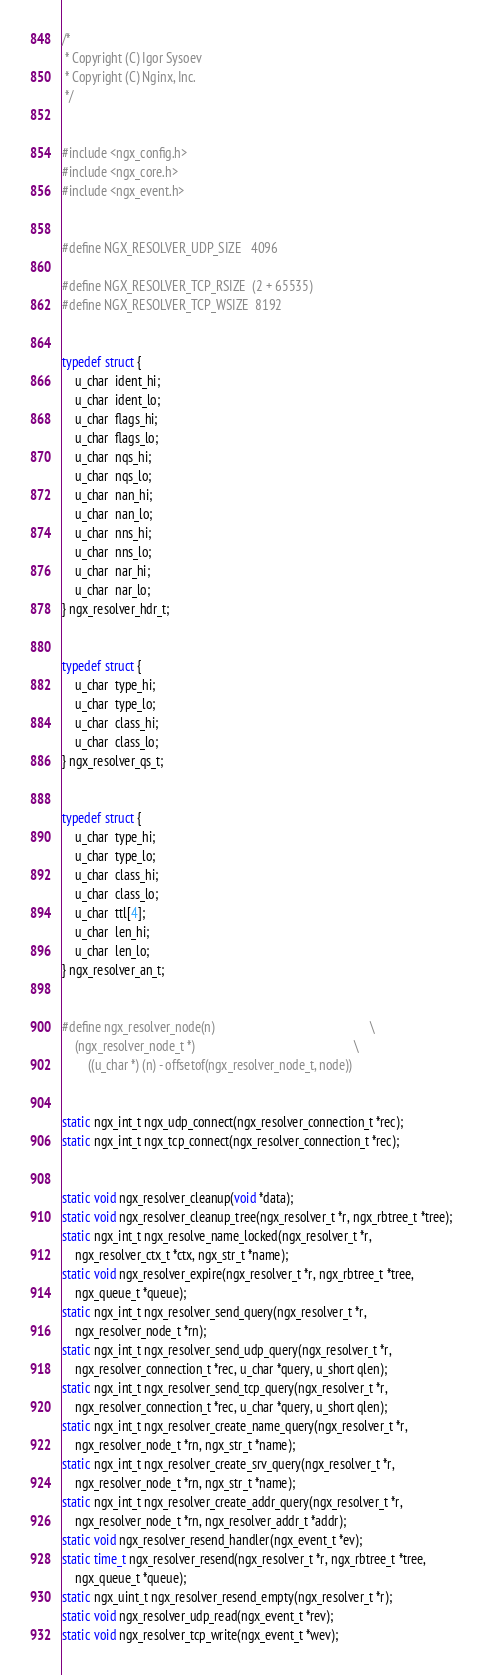Convert code to text. <code><loc_0><loc_0><loc_500><loc_500><_C_>
/*
 * Copyright (C) Igor Sysoev
 * Copyright (C) Nginx, Inc.
 */


#include <ngx_config.h>
#include <ngx_core.h>
#include <ngx_event.h>


#define NGX_RESOLVER_UDP_SIZE   4096

#define NGX_RESOLVER_TCP_RSIZE  (2 + 65535)
#define NGX_RESOLVER_TCP_WSIZE  8192


typedef struct {
    u_char  ident_hi;
    u_char  ident_lo;
    u_char  flags_hi;
    u_char  flags_lo;
    u_char  nqs_hi;
    u_char  nqs_lo;
    u_char  nan_hi;
    u_char  nan_lo;
    u_char  nns_hi;
    u_char  nns_lo;
    u_char  nar_hi;
    u_char  nar_lo;
} ngx_resolver_hdr_t;


typedef struct {
    u_char  type_hi;
    u_char  type_lo;
    u_char  class_hi;
    u_char  class_lo;
} ngx_resolver_qs_t;


typedef struct {
    u_char  type_hi;
    u_char  type_lo;
    u_char  class_hi;
    u_char  class_lo;
    u_char  ttl[4];
    u_char  len_hi;
    u_char  len_lo;
} ngx_resolver_an_t;


#define ngx_resolver_node(n)                                                 \
    (ngx_resolver_node_t *)                                                  \
        ((u_char *) (n) - offsetof(ngx_resolver_node_t, node))


static ngx_int_t ngx_udp_connect(ngx_resolver_connection_t *rec);
static ngx_int_t ngx_tcp_connect(ngx_resolver_connection_t *rec);


static void ngx_resolver_cleanup(void *data);
static void ngx_resolver_cleanup_tree(ngx_resolver_t *r, ngx_rbtree_t *tree);
static ngx_int_t ngx_resolve_name_locked(ngx_resolver_t *r,
    ngx_resolver_ctx_t *ctx, ngx_str_t *name);
static void ngx_resolver_expire(ngx_resolver_t *r, ngx_rbtree_t *tree,
    ngx_queue_t *queue);
static ngx_int_t ngx_resolver_send_query(ngx_resolver_t *r,
    ngx_resolver_node_t *rn);
static ngx_int_t ngx_resolver_send_udp_query(ngx_resolver_t *r,
    ngx_resolver_connection_t *rec, u_char *query, u_short qlen);
static ngx_int_t ngx_resolver_send_tcp_query(ngx_resolver_t *r,
    ngx_resolver_connection_t *rec, u_char *query, u_short qlen);
static ngx_int_t ngx_resolver_create_name_query(ngx_resolver_t *r,
    ngx_resolver_node_t *rn, ngx_str_t *name);
static ngx_int_t ngx_resolver_create_srv_query(ngx_resolver_t *r,
    ngx_resolver_node_t *rn, ngx_str_t *name);
static ngx_int_t ngx_resolver_create_addr_query(ngx_resolver_t *r,
    ngx_resolver_node_t *rn, ngx_resolver_addr_t *addr);
static void ngx_resolver_resend_handler(ngx_event_t *ev);
static time_t ngx_resolver_resend(ngx_resolver_t *r, ngx_rbtree_t *tree,
    ngx_queue_t *queue);
static ngx_uint_t ngx_resolver_resend_empty(ngx_resolver_t *r);
static void ngx_resolver_udp_read(ngx_event_t *rev);
static void ngx_resolver_tcp_write(ngx_event_t *wev);</code> 